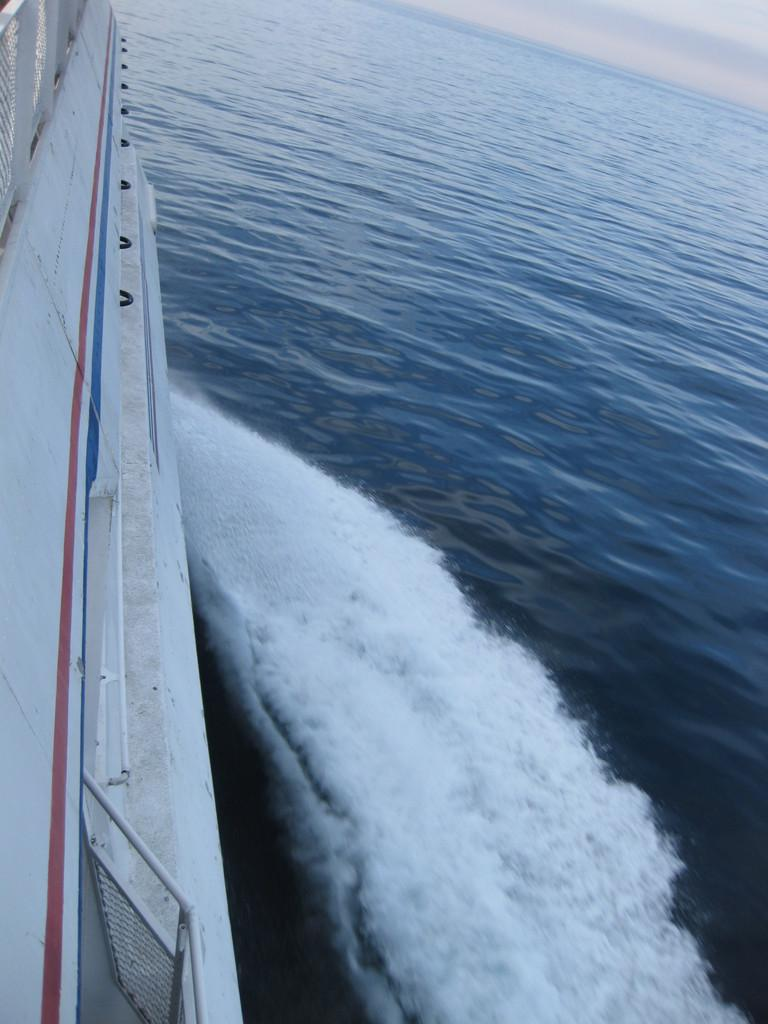What is the main subject of the image? There is a ship in the image. Where is the ship located? The ship is in the ocean. What else can be seen in the image besides the ship? The sky is visible in the image. Can you describe the sky in the image? There are clouds in the sky. Where is the cannon located on the ship in the image? There is no cannon present on the ship in the image. What note is the ship playing in the image? The ship is not playing a note, as it is an inanimate object and cannot produce music. 